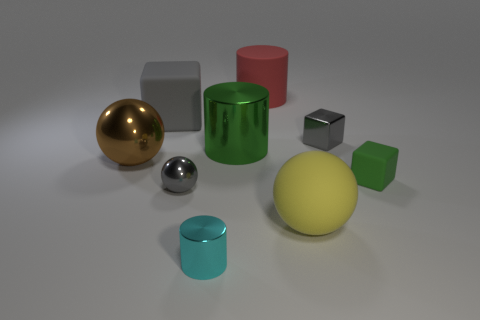What material is the big object that is the same color as the tiny metallic sphere?
Your answer should be very brief. Rubber. How many metal cylinders are the same color as the small matte cube?
Keep it short and to the point. 1. Are there the same number of brown shiny things that are on the right side of the cyan thing and big gray things?
Provide a short and direct response. No. What is the color of the large metallic sphere?
Keep it short and to the point. Brown. The green cylinder that is the same material as the brown sphere is what size?
Your answer should be compact. Large. What color is the tiny cube that is made of the same material as the cyan cylinder?
Make the answer very short. Gray. Is there a metallic cylinder that has the same size as the green matte cube?
Your answer should be compact. Yes. There is a gray thing that is the same shape as the big brown shiny thing; what is its material?
Provide a succinct answer. Metal. What shape is the gray metallic object that is the same size as the metal cube?
Your response must be concise. Sphere. Is there another brown shiny thing of the same shape as the brown shiny thing?
Offer a very short reply. No. 